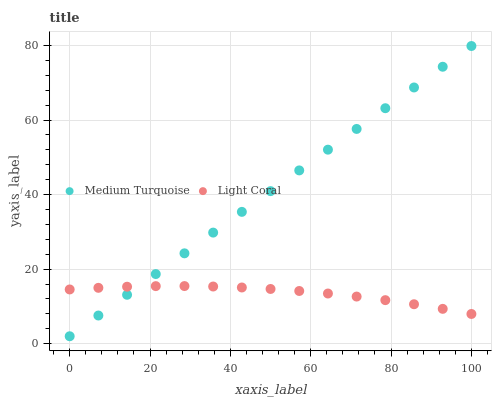Does Light Coral have the minimum area under the curve?
Answer yes or no. Yes. Does Medium Turquoise have the maximum area under the curve?
Answer yes or no. Yes. Does Medium Turquoise have the minimum area under the curve?
Answer yes or no. No. Is Medium Turquoise the smoothest?
Answer yes or no. Yes. Is Light Coral the roughest?
Answer yes or no. Yes. Is Medium Turquoise the roughest?
Answer yes or no. No. Does Medium Turquoise have the lowest value?
Answer yes or no. Yes. Does Medium Turquoise have the highest value?
Answer yes or no. Yes. Does Light Coral intersect Medium Turquoise?
Answer yes or no. Yes. Is Light Coral less than Medium Turquoise?
Answer yes or no. No. Is Light Coral greater than Medium Turquoise?
Answer yes or no. No. 